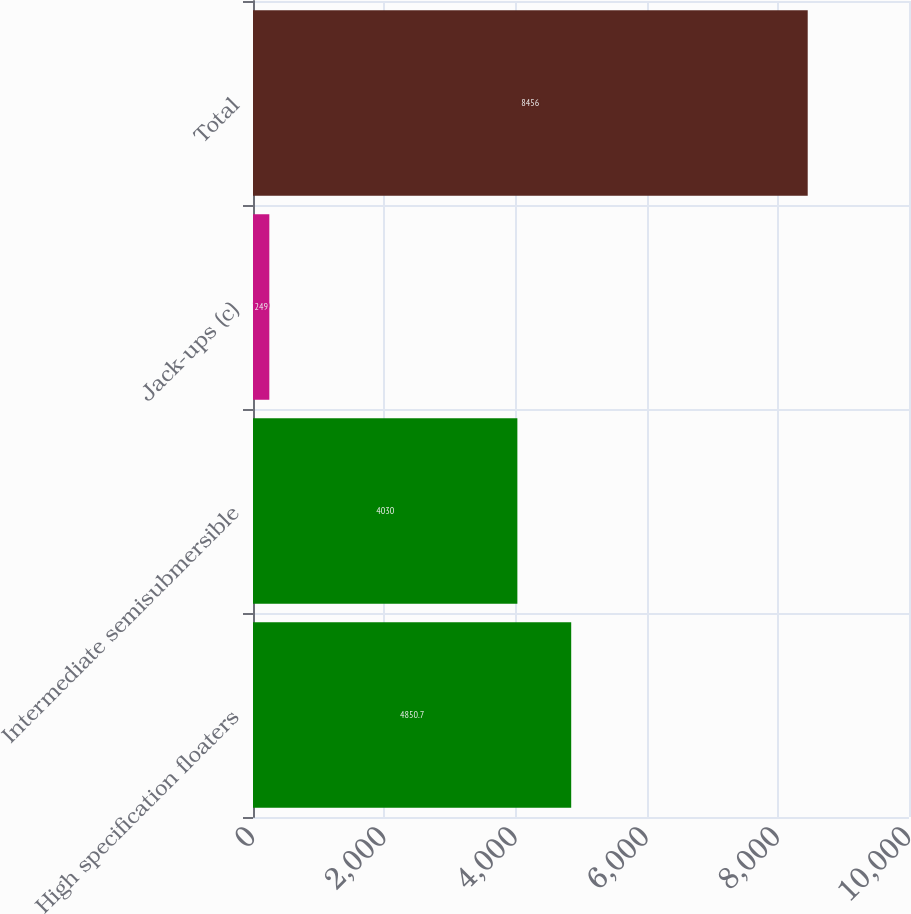Convert chart. <chart><loc_0><loc_0><loc_500><loc_500><bar_chart><fcel>High specification floaters<fcel>Intermediate semisubmersible<fcel>Jack-ups (c)<fcel>Total<nl><fcel>4850.7<fcel>4030<fcel>249<fcel>8456<nl></chart> 